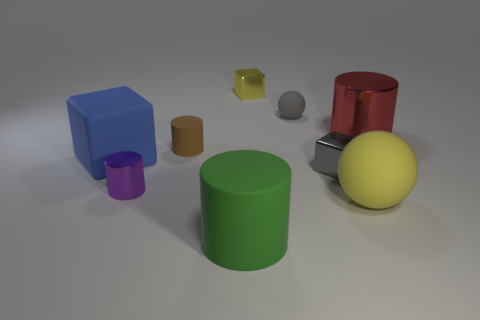How many yellow objects are made of the same material as the green cylinder?
Ensure brevity in your answer.  1. What number of cylinders are either green objects or rubber things?
Your response must be concise. 2. What is the size of the metal thing behind the big cylinder that is behind the tiny cylinder that is on the right side of the tiny purple metal thing?
Your response must be concise. Small. There is a cube that is on the right side of the blue thing and in front of the small matte cylinder; what is its color?
Provide a short and direct response. Gray. There is a gray block; does it have the same size as the matte cylinder behind the green rubber cylinder?
Make the answer very short. Yes. Is there anything else that has the same shape as the big green object?
Provide a succinct answer. Yes. There is another big object that is the same shape as the big green matte object; what is its color?
Your answer should be compact. Red. Is the purple metal object the same size as the gray shiny object?
Offer a terse response. Yes. How many other things are the same size as the yellow cube?
Your answer should be very brief. 4. What number of objects are either small metal cylinders that are in front of the red metallic cylinder or yellow objects behind the tiny rubber cylinder?
Ensure brevity in your answer.  2. 